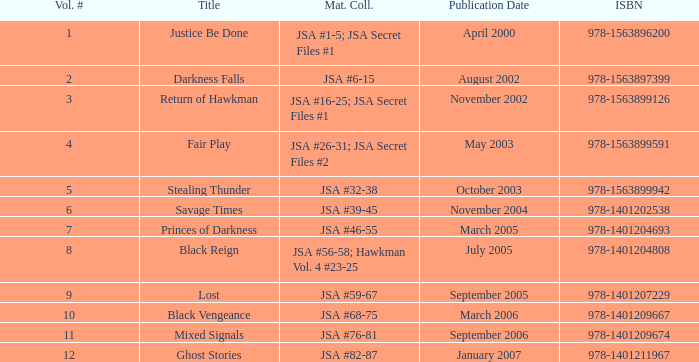What's the substance gathered for the 978-1401209674 isbn? JSA #76-81. 